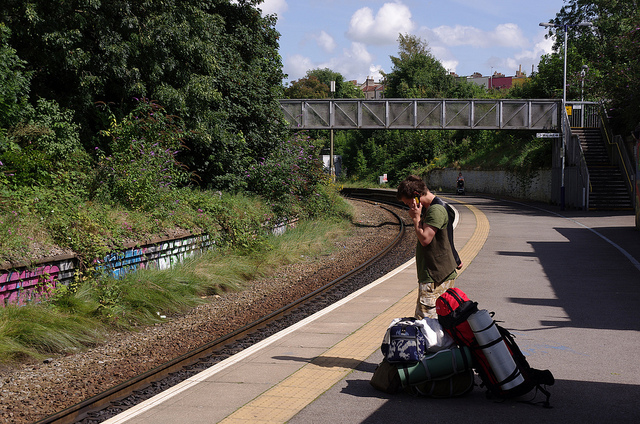If you had to cross to the other side how would you do it?
A. take taxi
B. overhead bridge
C. swing over
D. cross tracks
Answer with the option's letter from the given choices directly. The best way to cross to the other side is by using the overhead bridge (Option B). This method is safe and avoids the dangers associated with crossing tracks or swinging over. 